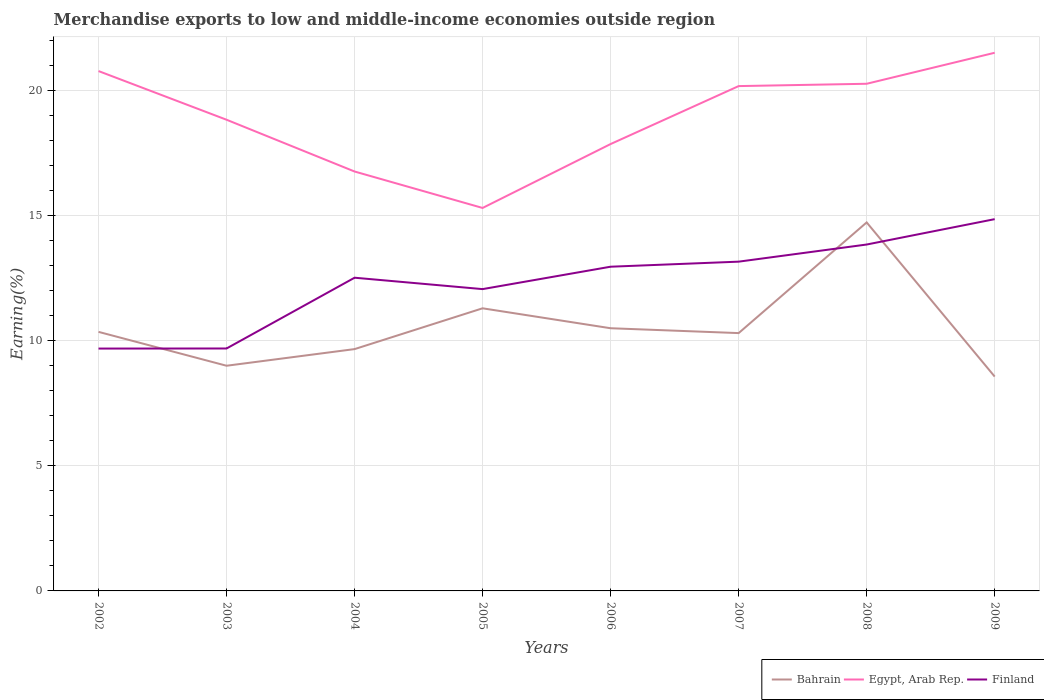How many different coloured lines are there?
Ensure brevity in your answer.  3. Does the line corresponding to Egypt, Arab Rep. intersect with the line corresponding to Finland?
Provide a succinct answer. No. Is the number of lines equal to the number of legend labels?
Offer a very short reply. Yes. Across all years, what is the maximum percentage of amount earned from merchandise exports in Bahrain?
Make the answer very short. 8.57. What is the total percentage of amount earned from merchandise exports in Egypt, Arab Rep. in the graph?
Make the answer very short. -1.1. What is the difference between the highest and the second highest percentage of amount earned from merchandise exports in Bahrain?
Offer a very short reply. 6.16. How many lines are there?
Your answer should be very brief. 3. What is the difference between two consecutive major ticks on the Y-axis?
Give a very brief answer. 5. Are the values on the major ticks of Y-axis written in scientific E-notation?
Keep it short and to the point. No. Does the graph contain any zero values?
Your answer should be very brief. No. Does the graph contain grids?
Your answer should be compact. Yes. How many legend labels are there?
Your response must be concise. 3. How are the legend labels stacked?
Offer a very short reply. Horizontal. What is the title of the graph?
Give a very brief answer. Merchandise exports to low and middle-income economies outside region. What is the label or title of the X-axis?
Make the answer very short. Years. What is the label or title of the Y-axis?
Ensure brevity in your answer.  Earning(%). What is the Earning(%) in Bahrain in 2002?
Give a very brief answer. 10.36. What is the Earning(%) of Egypt, Arab Rep. in 2002?
Provide a short and direct response. 20.78. What is the Earning(%) in Finland in 2002?
Your answer should be compact. 9.69. What is the Earning(%) in Bahrain in 2003?
Offer a very short reply. 9. What is the Earning(%) of Egypt, Arab Rep. in 2003?
Your answer should be very brief. 18.84. What is the Earning(%) of Finland in 2003?
Give a very brief answer. 9.69. What is the Earning(%) in Bahrain in 2004?
Make the answer very short. 9.67. What is the Earning(%) of Egypt, Arab Rep. in 2004?
Provide a succinct answer. 16.77. What is the Earning(%) of Finland in 2004?
Provide a short and direct response. 12.52. What is the Earning(%) of Bahrain in 2005?
Keep it short and to the point. 11.3. What is the Earning(%) in Egypt, Arab Rep. in 2005?
Your answer should be compact. 15.31. What is the Earning(%) in Finland in 2005?
Your response must be concise. 12.07. What is the Earning(%) in Bahrain in 2006?
Give a very brief answer. 10.5. What is the Earning(%) of Egypt, Arab Rep. in 2006?
Provide a succinct answer. 17.86. What is the Earning(%) in Finland in 2006?
Make the answer very short. 12.96. What is the Earning(%) in Bahrain in 2007?
Provide a succinct answer. 10.31. What is the Earning(%) in Egypt, Arab Rep. in 2007?
Make the answer very short. 20.18. What is the Earning(%) in Finland in 2007?
Provide a short and direct response. 13.16. What is the Earning(%) in Bahrain in 2008?
Ensure brevity in your answer.  14.73. What is the Earning(%) of Egypt, Arab Rep. in 2008?
Your response must be concise. 20.27. What is the Earning(%) of Finland in 2008?
Provide a succinct answer. 13.85. What is the Earning(%) of Bahrain in 2009?
Give a very brief answer. 8.57. What is the Earning(%) in Egypt, Arab Rep. in 2009?
Provide a short and direct response. 21.51. What is the Earning(%) in Finland in 2009?
Your answer should be very brief. 14.86. Across all years, what is the maximum Earning(%) in Bahrain?
Give a very brief answer. 14.73. Across all years, what is the maximum Earning(%) in Egypt, Arab Rep.?
Provide a short and direct response. 21.51. Across all years, what is the maximum Earning(%) of Finland?
Give a very brief answer. 14.86. Across all years, what is the minimum Earning(%) of Bahrain?
Ensure brevity in your answer.  8.57. Across all years, what is the minimum Earning(%) in Egypt, Arab Rep.?
Your answer should be very brief. 15.31. Across all years, what is the minimum Earning(%) in Finland?
Your answer should be compact. 9.69. What is the total Earning(%) in Bahrain in the graph?
Ensure brevity in your answer.  84.43. What is the total Earning(%) of Egypt, Arab Rep. in the graph?
Keep it short and to the point. 151.53. What is the total Earning(%) in Finland in the graph?
Make the answer very short. 98.8. What is the difference between the Earning(%) in Bahrain in 2002 and that in 2003?
Offer a terse response. 1.35. What is the difference between the Earning(%) of Egypt, Arab Rep. in 2002 and that in 2003?
Your response must be concise. 1.95. What is the difference between the Earning(%) in Finland in 2002 and that in 2003?
Provide a succinct answer. -0. What is the difference between the Earning(%) in Bahrain in 2002 and that in 2004?
Your answer should be very brief. 0.69. What is the difference between the Earning(%) of Egypt, Arab Rep. in 2002 and that in 2004?
Provide a succinct answer. 4.02. What is the difference between the Earning(%) of Finland in 2002 and that in 2004?
Offer a terse response. -2.83. What is the difference between the Earning(%) in Bahrain in 2002 and that in 2005?
Your answer should be compact. -0.94. What is the difference between the Earning(%) of Egypt, Arab Rep. in 2002 and that in 2005?
Provide a succinct answer. 5.47. What is the difference between the Earning(%) of Finland in 2002 and that in 2005?
Your answer should be compact. -2.38. What is the difference between the Earning(%) in Bahrain in 2002 and that in 2006?
Ensure brevity in your answer.  -0.14. What is the difference between the Earning(%) of Egypt, Arab Rep. in 2002 and that in 2006?
Offer a terse response. 2.92. What is the difference between the Earning(%) in Finland in 2002 and that in 2006?
Your answer should be compact. -3.27. What is the difference between the Earning(%) of Bahrain in 2002 and that in 2007?
Give a very brief answer. 0.05. What is the difference between the Earning(%) in Egypt, Arab Rep. in 2002 and that in 2007?
Give a very brief answer. 0.6. What is the difference between the Earning(%) in Finland in 2002 and that in 2007?
Provide a succinct answer. -3.47. What is the difference between the Earning(%) of Bahrain in 2002 and that in 2008?
Give a very brief answer. -4.38. What is the difference between the Earning(%) in Egypt, Arab Rep. in 2002 and that in 2008?
Provide a succinct answer. 0.51. What is the difference between the Earning(%) of Finland in 2002 and that in 2008?
Offer a terse response. -4.16. What is the difference between the Earning(%) in Bahrain in 2002 and that in 2009?
Offer a terse response. 1.79. What is the difference between the Earning(%) in Egypt, Arab Rep. in 2002 and that in 2009?
Your answer should be very brief. -0.73. What is the difference between the Earning(%) of Finland in 2002 and that in 2009?
Keep it short and to the point. -5.17. What is the difference between the Earning(%) in Bahrain in 2003 and that in 2004?
Provide a short and direct response. -0.67. What is the difference between the Earning(%) of Egypt, Arab Rep. in 2003 and that in 2004?
Give a very brief answer. 2.07. What is the difference between the Earning(%) in Finland in 2003 and that in 2004?
Keep it short and to the point. -2.83. What is the difference between the Earning(%) in Bahrain in 2003 and that in 2005?
Your answer should be compact. -2.3. What is the difference between the Earning(%) in Egypt, Arab Rep. in 2003 and that in 2005?
Offer a terse response. 3.53. What is the difference between the Earning(%) in Finland in 2003 and that in 2005?
Ensure brevity in your answer.  -2.37. What is the difference between the Earning(%) of Bahrain in 2003 and that in 2006?
Offer a terse response. -1.5. What is the difference between the Earning(%) in Egypt, Arab Rep. in 2003 and that in 2006?
Provide a succinct answer. 0.97. What is the difference between the Earning(%) in Finland in 2003 and that in 2006?
Offer a terse response. -3.27. What is the difference between the Earning(%) of Bahrain in 2003 and that in 2007?
Provide a short and direct response. -1.3. What is the difference between the Earning(%) in Egypt, Arab Rep. in 2003 and that in 2007?
Your answer should be compact. -1.34. What is the difference between the Earning(%) of Finland in 2003 and that in 2007?
Offer a very short reply. -3.47. What is the difference between the Earning(%) in Bahrain in 2003 and that in 2008?
Offer a terse response. -5.73. What is the difference between the Earning(%) of Egypt, Arab Rep. in 2003 and that in 2008?
Offer a terse response. -1.44. What is the difference between the Earning(%) of Finland in 2003 and that in 2008?
Provide a succinct answer. -4.16. What is the difference between the Earning(%) in Bahrain in 2003 and that in 2009?
Ensure brevity in your answer.  0.43. What is the difference between the Earning(%) of Egypt, Arab Rep. in 2003 and that in 2009?
Your response must be concise. -2.68. What is the difference between the Earning(%) in Finland in 2003 and that in 2009?
Your response must be concise. -5.17. What is the difference between the Earning(%) in Bahrain in 2004 and that in 2005?
Make the answer very short. -1.63. What is the difference between the Earning(%) in Egypt, Arab Rep. in 2004 and that in 2005?
Your response must be concise. 1.46. What is the difference between the Earning(%) of Finland in 2004 and that in 2005?
Offer a very short reply. 0.46. What is the difference between the Earning(%) in Bahrain in 2004 and that in 2006?
Offer a very short reply. -0.83. What is the difference between the Earning(%) in Egypt, Arab Rep. in 2004 and that in 2006?
Ensure brevity in your answer.  -1.1. What is the difference between the Earning(%) of Finland in 2004 and that in 2006?
Provide a succinct answer. -0.44. What is the difference between the Earning(%) in Bahrain in 2004 and that in 2007?
Ensure brevity in your answer.  -0.64. What is the difference between the Earning(%) in Egypt, Arab Rep. in 2004 and that in 2007?
Your answer should be compact. -3.41. What is the difference between the Earning(%) of Finland in 2004 and that in 2007?
Your response must be concise. -0.64. What is the difference between the Earning(%) in Bahrain in 2004 and that in 2008?
Your response must be concise. -5.06. What is the difference between the Earning(%) in Egypt, Arab Rep. in 2004 and that in 2008?
Your answer should be very brief. -3.51. What is the difference between the Earning(%) of Finland in 2004 and that in 2008?
Provide a short and direct response. -1.33. What is the difference between the Earning(%) of Bahrain in 2004 and that in 2009?
Make the answer very short. 1.1. What is the difference between the Earning(%) in Egypt, Arab Rep. in 2004 and that in 2009?
Your answer should be compact. -4.75. What is the difference between the Earning(%) of Finland in 2004 and that in 2009?
Your response must be concise. -2.34. What is the difference between the Earning(%) of Bahrain in 2005 and that in 2006?
Give a very brief answer. 0.8. What is the difference between the Earning(%) of Egypt, Arab Rep. in 2005 and that in 2006?
Provide a short and direct response. -2.56. What is the difference between the Earning(%) in Finland in 2005 and that in 2006?
Provide a succinct answer. -0.9. What is the difference between the Earning(%) in Bahrain in 2005 and that in 2007?
Your answer should be very brief. 0.99. What is the difference between the Earning(%) in Egypt, Arab Rep. in 2005 and that in 2007?
Offer a very short reply. -4.87. What is the difference between the Earning(%) in Finland in 2005 and that in 2007?
Offer a terse response. -1.1. What is the difference between the Earning(%) of Bahrain in 2005 and that in 2008?
Make the answer very short. -3.43. What is the difference between the Earning(%) in Egypt, Arab Rep. in 2005 and that in 2008?
Provide a short and direct response. -4.96. What is the difference between the Earning(%) in Finland in 2005 and that in 2008?
Keep it short and to the point. -1.78. What is the difference between the Earning(%) in Bahrain in 2005 and that in 2009?
Your answer should be very brief. 2.73. What is the difference between the Earning(%) in Egypt, Arab Rep. in 2005 and that in 2009?
Your answer should be compact. -6.2. What is the difference between the Earning(%) of Finland in 2005 and that in 2009?
Give a very brief answer. -2.8. What is the difference between the Earning(%) in Bahrain in 2006 and that in 2007?
Give a very brief answer. 0.19. What is the difference between the Earning(%) in Egypt, Arab Rep. in 2006 and that in 2007?
Offer a very short reply. -2.32. What is the difference between the Earning(%) of Finland in 2006 and that in 2007?
Make the answer very short. -0.2. What is the difference between the Earning(%) in Bahrain in 2006 and that in 2008?
Keep it short and to the point. -4.23. What is the difference between the Earning(%) of Egypt, Arab Rep. in 2006 and that in 2008?
Provide a short and direct response. -2.41. What is the difference between the Earning(%) in Finland in 2006 and that in 2008?
Your response must be concise. -0.89. What is the difference between the Earning(%) in Bahrain in 2006 and that in 2009?
Your response must be concise. 1.93. What is the difference between the Earning(%) of Egypt, Arab Rep. in 2006 and that in 2009?
Your response must be concise. -3.65. What is the difference between the Earning(%) in Finland in 2006 and that in 2009?
Ensure brevity in your answer.  -1.9. What is the difference between the Earning(%) of Bahrain in 2007 and that in 2008?
Make the answer very short. -4.42. What is the difference between the Earning(%) in Egypt, Arab Rep. in 2007 and that in 2008?
Offer a very short reply. -0.09. What is the difference between the Earning(%) of Finland in 2007 and that in 2008?
Give a very brief answer. -0.68. What is the difference between the Earning(%) of Bahrain in 2007 and that in 2009?
Your response must be concise. 1.74. What is the difference between the Earning(%) of Egypt, Arab Rep. in 2007 and that in 2009?
Offer a very short reply. -1.33. What is the difference between the Earning(%) in Finland in 2007 and that in 2009?
Give a very brief answer. -1.7. What is the difference between the Earning(%) of Bahrain in 2008 and that in 2009?
Offer a very short reply. 6.16. What is the difference between the Earning(%) of Egypt, Arab Rep. in 2008 and that in 2009?
Give a very brief answer. -1.24. What is the difference between the Earning(%) in Finland in 2008 and that in 2009?
Provide a short and direct response. -1.01. What is the difference between the Earning(%) in Bahrain in 2002 and the Earning(%) in Egypt, Arab Rep. in 2003?
Your answer should be compact. -8.48. What is the difference between the Earning(%) in Bahrain in 2002 and the Earning(%) in Finland in 2003?
Your response must be concise. 0.66. What is the difference between the Earning(%) of Egypt, Arab Rep. in 2002 and the Earning(%) of Finland in 2003?
Your answer should be very brief. 11.09. What is the difference between the Earning(%) in Bahrain in 2002 and the Earning(%) in Egypt, Arab Rep. in 2004?
Keep it short and to the point. -6.41. What is the difference between the Earning(%) of Bahrain in 2002 and the Earning(%) of Finland in 2004?
Your response must be concise. -2.16. What is the difference between the Earning(%) of Egypt, Arab Rep. in 2002 and the Earning(%) of Finland in 2004?
Give a very brief answer. 8.26. What is the difference between the Earning(%) of Bahrain in 2002 and the Earning(%) of Egypt, Arab Rep. in 2005?
Keep it short and to the point. -4.95. What is the difference between the Earning(%) in Bahrain in 2002 and the Earning(%) in Finland in 2005?
Your response must be concise. -1.71. What is the difference between the Earning(%) in Egypt, Arab Rep. in 2002 and the Earning(%) in Finland in 2005?
Make the answer very short. 8.72. What is the difference between the Earning(%) of Bahrain in 2002 and the Earning(%) of Egypt, Arab Rep. in 2006?
Your response must be concise. -7.51. What is the difference between the Earning(%) of Bahrain in 2002 and the Earning(%) of Finland in 2006?
Give a very brief answer. -2.6. What is the difference between the Earning(%) of Egypt, Arab Rep. in 2002 and the Earning(%) of Finland in 2006?
Your response must be concise. 7.82. What is the difference between the Earning(%) of Bahrain in 2002 and the Earning(%) of Egypt, Arab Rep. in 2007?
Your answer should be compact. -9.83. What is the difference between the Earning(%) in Bahrain in 2002 and the Earning(%) in Finland in 2007?
Offer a terse response. -2.81. What is the difference between the Earning(%) in Egypt, Arab Rep. in 2002 and the Earning(%) in Finland in 2007?
Give a very brief answer. 7.62. What is the difference between the Earning(%) in Bahrain in 2002 and the Earning(%) in Egypt, Arab Rep. in 2008?
Give a very brief answer. -9.92. What is the difference between the Earning(%) in Bahrain in 2002 and the Earning(%) in Finland in 2008?
Ensure brevity in your answer.  -3.49. What is the difference between the Earning(%) of Egypt, Arab Rep. in 2002 and the Earning(%) of Finland in 2008?
Give a very brief answer. 6.93. What is the difference between the Earning(%) in Bahrain in 2002 and the Earning(%) in Egypt, Arab Rep. in 2009?
Provide a succinct answer. -11.16. What is the difference between the Earning(%) of Bahrain in 2002 and the Earning(%) of Finland in 2009?
Your answer should be compact. -4.51. What is the difference between the Earning(%) in Egypt, Arab Rep. in 2002 and the Earning(%) in Finland in 2009?
Offer a very short reply. 5.92. What is the difference between the Earning(%) in Bahrain in 2003 and the Earning(%) in Egypt, Arab Rep. in 2004?
Your answer should be very brief. -7.76. What is the difference between the Earning(%) of Bahrain in 2003 and the Earning(%) of Finland in 2004?
Provide a short and direct response. -3.52. What is the difference between the Earning(%) of Egypt, Arab Rep. in 2003 and the Earning(%) of Finland in 2004?
Offer a very short reply. 6.32. What is the difference between the Earning(%) of Bahrain in 2003 and the Earning(%) of Egypt, Arab Rep. in 2005?
Your answer should be compact. -6.31. What is the difference between the Earning(%) in Bahrain in 2003 and the Earning(%) in Finland in 2005?
Your response must be concise. -3.06. What is the difference between the Earning(%) of Egypt, Arab Rep. in 2003 and the Earning(%) of Finland in 2005?
Offer a very short reply. 6.77. What is the difference between the Earning(%) of Bahrain in 2003 and the Earning(%) of Egypt, Arab Rep. in 2006?
Ensure brevity in your answer.  -8.86. What is the difference between the Earning(%) of Bahrain in 2003 and the Earning(%) of Finland in 2006?
Ensure brevity in your answer.  -3.96. What is the difference between the Earning(%) in Egypt, Arab Rep. in 2003 and the Earning(%) in Finland in 2006?
Your response must be concise. 5.88. What is the difference between the Earning(%) in Bahrain in 2003 and the Earning(%) in Egypt, Arab Rep. in 2007?
Your answer should be compact. -11.18. What is the difference between the Earning(%) in Bahrain in 2003 and the Earning(%) in Finland in 2007?
Offer a very short reply. -4.16. What is the difference between the Earning(%) in Egypt, Arab Rep. in 2003 and the Earning(%) in Finland in 2007?
Provide a succinct answer. 5.67. What is the difference between the Earning(%) of Bahrain in 2003 and the Earning(%) of Egypt, Arab Rep. in 2008?
Offer a very short reply. -11.27. What is the difference between the Earning(%) in Bahrain in 2003 and the Earning(%) in Finland in 2008?
Keep it short and to the point. -4.85. What is the difference between the Earning(%) of Egypt, Arab Rep. in 2003 and the Earning(%) of Finland in 2008?
Ensure brevity in your answer.  4.99. What is the difference between the Earning(%) of Bahrain in 2003 and the Earning(%) of Egypt, Arab Rep. in 2009?
Offer a very short reply. -12.51. What is the difference between the Earning(%) in Bahrain in 2003 and the Earning(%) in Finland in 2009?
Offer a terse response. -5.86. What is the difference between the Earning(%) in Egypt, Arab Rep. in 2003 and the Earning(%) in Finland in 2009?
Your answer should be compact. 3.97. What is the difference between the Earning(%) of Bahrain in 2004 and the Earning(%) of Egypt, Arab Rep. in 2005?
Keep it short and to the point. -5.64. What is the difference between the Earning(%) in Bahrain in 2004 and the Earning(%) in Finland in 2005?
Make the answer very short. -2.4. What is the difference between the Earning(%) of Egypt, Arab Rep. in 2004 and the Earning(%) of Finland in 2005?
Provide a succinct answer. 4.7. What is the difference between the Earning(%) in Bahrain in 2004 and the Earning(%) in Egypt, Arab Rep. in 2006?
Give a very brief answer. -8.2. What is the difference between the Earning(%) in Bahrain in 2004 and the Earning(%) in Finland in 2006?
Your response must be concise. -3.29. What is the difference between the Earning(%) of Egypt, Arab Rep. in 2004 and the Earning(%) of Finland in 2006?
Your answer should be compact. 3.81. What is the difference between the Earning(%) of Bahrain in 2004 and the Earning(%) of Egypt, Arab Rep. in 2007?
Give a very brief answer. -10.51. What is the difference between the Earning(%) in Bahrain in 2004 and the Earning(%) in Finland in 2007?
Ensure brevity in your answer.  -3.5. What is the difference between the Earning(%) of Egypt, Arab Rep. in 2004 and the Earning(%) of Finland in 2007?
Make the answer very short. 3.6. What is the difference between the Earning(%) in Bahrain in 2004 and the Earning(%) in Egypt, Arab Rep. in 2008?
Your answer should be compact. -10.61. What is the difference between the Earning(%) of Bahrain in 2004 and the Earning(%) of Finland in 2008?
Your answer should be very brief. -4.18. What is the difference between the Earning(%) of Egypt, Arab Rep. in 2004 and the Earning(%) of Finland in 2008?
Offer a terse response. 2.92. What is the difference between the Earning(%) in Bahrain in 2004 and the Earning(%) in Egypt, Arab Rep. in 2009?
Provide a succinct answer. -11.85. What is the difference between the Earning(%) of Bahrain in 2004 and the Earning(%) of Finland in 2009?
Make the answer very short. -5.2. What is the difference between the Earning(%) of Egypt, Arab Rep. in 2004 and the Earning(%) of Finland in 2009?
Your answer should be compact. 1.9. What is the difference between the Earning(%) of Bahrain in 2005 and the Earning(%) of Egypt, Arab Rep. in 2006?
Your answer should be very brief. -6.57. What is the difference between the Earning(%) in Bahrain in 2005 and the Earning(%) in Finland in 2006?
Offer a very short reply. -1.66. What is the difference between the Earning(%) in Egypt, Arab Rep. in 2005 and the Earning(%) in Finland in 2006?
Provide a short and direct response. 2.35. What is the difference between the Earning(%) of Bahrain in 2005 and the Earning(%) of Egypt, Arab Rep. in 2007?
Your response must be concise. -8.88. What is the difference between the Earning(%) in Bahrain in 2005 and the Earning(%) in Finland in 2007?
Keep it short and to the point. -1.86. What is the difference between the Earning(%) of Egypt, Arab Rep. in 2005 and the Earning(%) of Finland in 2007?
Provide a short and direct response. 2.15. What is the difference between the Earning(%) of Bahrain in 2005 and the Earning(%) of Egypt, Arab Rep. in 2008?
Provide a succinct answer. -8.98. What is the difference between the Earning(%) in Bahrain in 2005 and the Earning(%) in Finland in 2008?
Keep it short and to the point. -2.55. What is the difference between the Earning(%) in Egypt, Arab Rep. in 2005 and the Earning(%) in Finland in 2008?
Give a very brief answer. 1.46. What is the difference between the Earning(%) in Bahrain in 2005 and the Earning(%) in Egypt, Arab Rep. in 2009?
Your response must be concise. -10.22. What is the difference between the Earning(%) in Bahrain in 2005 and the Earning(%) in Finland in 2009?
Provide a short and direct response. -3.56. What is the difference between the Earning(%) of Egypt, Arab Rep. in 2005 and the Earning(%) of Finland in 2009?
Give a very brief answer. 0.45. What is the difference between the Earning(%) in Bahrain in 2006 and the Earning(%) in Egypt, Arab Rep. in 2007?
Your answer should be compact. -9.68. What is the difference between the Earning(%) of Bahrain in 2006 and the Earning(%) of Finland in 2007?
Keep it short and to the point. -2.66. What is the difference between the Earning(%) of Egypt, Arab Rep. in 2006 and the Earning(%) of Finland in 2007?
Provide a short and direct response. 4.7. What is the difference between the Earning(%) in Bahrain in 2006 and the Earning(%) in Egypt, Arab Rep. in 2008?
Provide a short and direct response. -9.77. What is the difference between the Earning(%) of Bahrain in 2006 and the Earning(%) of Finland in 2008?
Provide a short and direct response. -3.35. What is the difference between the Earning(%) of Egypt, Arab Rep. in 2006 and the Earning(%) of Finland in 2008?
Ensure brevity in your answer.  4.02. What is the difference between the Earning(%) in Bahrain in 2006 and the Earning(%) in Egypt, Arab Rep. in 2009?
Make the answer very short. -11.01. What is the difference between the Earning(%) in Bahrain in 2006 and the Earning(%) in Finland in 2009?
Your answer should be compact. -4.36. What is the difference between the Earning(%) of Egypt, Arab Rep. in 2006 and the Earning(%) of Finland in 2009?
Make the answer very short. 3. What is the difference between the Earning(%) in Bahrain in 2007 and the Earning(%) in Egypt, Arab Rep. in 2008?
Keep it short and to the point. -9.97. What is the difference between the Earning(%) in Bahrain in 2007 and the Earning(%) in Finland in 2008?
Keep it short and to the point. -3.54. What is the difference between the Earning(%) in Egypt, Arab Rep. in 2007 and the Earning(%) in Finland in 2008?
Your response must be concise. 6.33. What is the difference between the Earning(%) in Bahrain in 2007 and the Earning(%) in Egypt, Arab Rep. in 2009?
Keep it short and to the point. -11.21. What is the difference between the Earning(%) in Bahrain in 2007 and the Earning(%) in Finland in 2009?
Your answer should be very brief. -4.56. What is the difference between the Earning(%) of Egypt, Arab Rep. in 2007 and the Earning(%) of Finland in 2009?
Ensure brevity in your answer.  5.32. What is the difference between the Earning(%) in Bahrain in 2008 and the Earning(%) in Egypt, Arab Rep. in 2009?
Offer a very short reply. -6.78. What is the difference between the Earning(%) in Bahrain in 2008 and the Earning(%) in Finland in 2009?
Give a very brief answer. -0.13. What is the difference between the Earning(%) of Egypt, Arab Rep. in 2008 and the Earning(%) of Finland in 2009?
Your answer should be very brief. 5.41. What is the average Earning(%) in Bahrain per year?
Offer a very short reply. 10.55. What is the average Earning(%) of Egypt, Arab Rep. per year?
Offer a terse response. 18.94. What is the average Earning(%) in Finland per year?
Your answer should be compact. 12.35. In the year 2002, what is the difference between the Earning(%) in Bahrain and Earning(%) in Egypt, Arab Rep.?
Keep it short and to the point. -10.43. In the year 2002, what is the difference between the Earning(%) of Bahrain and Earning(%) of Finland?
Make the answer very short. 0.67. In the year 2002, what is the difference between the Earning(%) in Egypt, Arab Rep. and Earning(%) in Finland?
Provide a succinct answer. 11.09. In the year 2003, what is the difference between the Earning(%) in Bahrain and Earning(%) in Egypt, Arab Rep.?
Your answer should be very brief. -9.83. In the year 2003, what is the difference between the Earning(%) of Bahrain and Earning(%) of Finland?
Provide a succinct answer. -0.69. In the year 2003, what is the difference between the Earning(%) in Egypt, Arab Rep. and Earning(%) in Finland?
Offer a terse response. 9.14. In the year 2004, what is the difference between the Earning(%) in Bahrain and Earning(%) in Egypt, Arab Rep.?
Keep it short and to the point. -7.1. In the year 2004, what is the difference between the Earning(%) of Bahrain and Earning(%) of Finland?
Offer a terse response. -2.85. In the year 2004, what is the difference between the Earning(%) of Egypt, Arab Rep. and Earning(%) of Finland?
Your answer should be very brief. 4.25. In the year 2005, what is the difference between the Earning(%) of Bahrain and Earning(%) of Egypt, Arab Rep.?
Offer a very short reply. -4.01. In the year 2005, what is the difference between the Earning(%) in Bahrain and Earning(%) in Finland?
Offer a terse response. -0.77. In the year 2005, what is the difference between the Earning(%) in Egypt, Arab Rep. and Earning(%) in Finland?
Your answer should be compact. 3.24. In the year 2006, what is the difference between the Earning(%) of Bahrain and Earning(%) of Egypt, Arab Rep.?
Give a very brief answer. -7.36. In the year 2006, what is the difference between the Earning(%) in Bahrain and Earning(%) in Finland?
Your answer should be compact. -2.46. In the year 2006, what is the difference between the Earning(%) of Egypt, Arab Rep. and Earning(%) of Finland?
Offer a terse response. 4.9. In the year 2007, what is the difference between the Earning(%) of Bahrain and Earning(%) of Egypt, Arab Rep.?
Your answer should be very brief. -9.87. In the year 2007, what is the difference between the Earning(%) in Bahrain and Earning(%) in Finland?
Ensure brevity in your answer.  -2.86. In the year 2007, what is the difference between the Earning(%) in Egypt, Arab Rep. and Earning(%) in Finland?
Give a very brief answer. 7.02. In the year 2008, what is the difference between the Earning(%) of Bahrain and Earning(%) of Egypt, Arab Rep.?
Offer a terse response. -5.54. In the year 2008, what is the difference between the Earning(%) of Bahrain and Earning(%) of Finland?
Keep it short and to the point. 0.88. In the year 2008, what is the difference between the Earning(%) in Egypt, Arab Rep. and Earning(%) in Finland?
Give a very brief answer. 6.43. In the year 2009, what is the difference between the Earning(%) in Bahrain and Earning(%) in Egypt, Arab Rep.?
Offer a very short reply. -12.95. In the year 2009, what is the difference between the Earning(%) in Bahrain and Earning(%) in Finland?
Keep it short and to the point. -6.29. In the year 2009, what is the difference between the Earning(%) of Egypt, Arab Rep. and Earning(%) of Finland?
Keep it short and to the point. 6.65. What is the ratio of the Earning(%) in Bahrain in 2002 to that in 2003?
Your answer should be compact. 1.15. What is the ratio of the Earning(%) in Egypt, Arab Rep. in 2002 to that in 2003?
Offer a very short reply. 1.1. What is the ratio of the Earning(%) of Finland in 2002 to that in 2003?
Give a very brief answer. 1. What is the ratio of the Earning(%) in Bahrain in 2002 to that in 2004?
Offer a very short reply. 1.07. What is the ratio of the Earning(%) in Egypt, Arab Rep. in 2002 to that in 2004?
Your answer should be very brief. 1.24. What is the ratio of the Earning(%) in Finland in 2002 to that in 2004?
Make the answer very short. 0.77. What is the ratio of the Earning(%) of Bahrain in 2002 to that in 2005?
Make the answer very short. 0.92. What is the ratio of the Earning(%) of Egypt, Arab Rep. in 2002 to that in 2005?
Make the answer very short. 1.36. What is the ratio of the Earning(%) of Finland in 2002 to that in 2005?
Provide a short and direct response. 0.8. What is the ratio of the Earning(%) of Bahrain in 2002 to that in 2006?
Your response must be concise. 0.99. What is the ratio of the Earning(%) in Egypt, Arab Rep. in 2002 to that in 2006?
Offer a very short reply. 1.16. What is the ratio of the Earning(%) of Finland in 2002 to that in 2006?
Your answer should be very brief. 0.75. What is the ratio of the Earning(%) of Egypt, Arab Rep. in 2002 to that in 2007?
Ensure brevity in your answer.  1.03. What is the ratio of the Earning(%) in Finland in 2002 to that in 2007?
Offer a terse response. 0.74. What is the ratio of the Earning(%) in Bahrain in 2002 to that in 2008?
Offer a terse response. 0.7. What is the ratio of the Earning(%) of Egypt, Arab Rep. in 2002 to that in 2008?
Provide a succinct answer. 1.03. What is the ratio of the Earning(%) in Finland in 2002 to that in 2008?
Offer a terse response. 0.7. What is the ratio of the Earning(%) in Bahrain in 2002 to that in 2009?
Your answer should be very brief. 1.21. What is the ratio of the Earning(%) of Finland in 2002 to that in 2009?
Ensure brevity in your answer.  0.65. What is the ratio of the Earning(%) in Bahrain in 2003 to that in 2004?
Give a very brief answer. 0.93. What is the ratio of the Earning(%) of Egypt, Arab Rep. in 2003 to that in 2004?
Your answer should be compact. 1.12. What is the ratio of the Earning(%) of Finland in 2003 to that in 2004?
Give a very brief answer. 0.77. What is the ratio of the Earning(%) in Bahrain in 2003 to that in 2005?
Provide a short and direct response. 0.8. What is the ratio of the Earning(%) in Egypt, Arab Rep. in 2003 to that in 2005?
Offer a terse response. 1.23. What is the ratio of the Earning(%) in Finland in 2003 to that in 2005?
Offer a terse response. 0.8. What is the ratio of the Earning(%) in Bahrain in 2003 to that in 2006?
Your answer should be very brief. 0.86. What is the ratio of the Earning(%) in Egypt, Arab Rep. in 2003 to that in 2006?
Make the answer very short. 1.05. What is the ratio of the Earning(%) in Finland in 2003 to that in 2006?
Your response must be concise. 0.75. What is the ratio of the Earning(%) in Bahrain in 2003 to that in 2007?
Give a very brief answer. 0.87. What is the ratio of the Earning(%) in Egypt, Arab Rep. in 2003 to that in 2007?
Keep it short and to the point. 0.93. What is the ratio of the Earning(%) in Finland in 2003 to that in 2007?
Your answer should be compact. 0.74. What is the ratio of the Earning(%) of Bahrain in 2003 to that in 2008?
Your answer should be very brief. 0.61. What is the ratio of the Earning(%) in Egypt, Arab Rep. in 2003 to that in 2008?
Your answer should be compact. 0.93. What is the ratio of the Earning(%) of Finland in 2003 to that in 2008?
Your response must be concise. 0.7. What is the ratio of the Earning(%) of Bahrain in 2003 to that in 2009?
Give a very brief answer. 1.05. What is the ratio of the Earning(%) in Egypt, Arab Rep. in 2003 to that in 2009?
Ensure brevity in your answer.  0.88. What is the ratio of the Earning(%) in Finland in 2003 to that in 2009?
Your answer should be compact. 0.65. What is the ratio of the Earning(%) in Bahrain in 2004 to that in 2005?
Offer a very short reply. 0.86. What is the ratio of the Earning(%) in Egypt, Arab Rep. in 2004 to that in 2005?
Offer a very short reply. 1.1. What is the ratio of the Earning(%) of Finland in 2004 to that in 2005?
Offer a terse response. 1.04. What is the ratio of the Earning(%) of Bahrain in 2004 to that in 2006?
Your response must be concise. 0.92. What is the ratio of the Earning(%) in Egypt, Arab Rep. in 2004 to that in 2006?
Offer a very short reply. 0.94. What is the ratio of the Earning(%) in Finland in 2004 to that in 2006?
Keep it short and to the point. 0.97. What is the ratio of the Earning(%) in Bahrain in 2004 to that in 2007?
Your answer should be very brief. 0.94. What is the ratio of the Earning(%) of Egypt, Arab Rep. in 2004 to that in 2007?
Provide a succinct answer. 0.83. What is the ratio of the Earning(%) in Finland in 2004 to that in 2007?
Provide a short and direct response. 0.95. What is the ratio of the Earning(%) of Bahrain in 2004 to that in 2008?
Keep it short and to the point. 0.66. What is the ratio of the Earning(%) of Egypt, Arab Rep. in 2004 to that in 2008?
Your response must be concise. 0.83. What is the ratio of the Earning(%) of Finland in 2004 to that in 2008?
Ensure brevity in your answer.  0.9. What is the ratio of the Earning(%) in Bahrain in 2004 to that in 2009?
Give a very brief answer. 1.13. What is the ratio of the Earning(%) of Egypt, Arab Rep. in 2004 to that in 2009?
Offer a terse response. 0.78. What is the ratio of the Earning(%) of Finland in 2004 to that in 2009?
Keep it short and to the point. 0.84. What is the ratio of the Earning(%) in Bahrain in 2005 to that in 2006?
Provide a short and direct response. 1.08. What is the ratio of the Earning(%) of Egypt, Arab Rep. in 2005 to that in 2006?
Offer a terse response. 0.86. What is the ratio of the Earning(%) in Finland in 2005 to that in 2006?
Ensure brevity in your answer.  0.93. What is the ratio of the Earning(%) of Bahrain in 2005 to that in 2007?
Provide a succinct answer. 1.1. What is the ratio of the Earning(%) in Egypt, Arab Rep. in 2005 to that in 2007?
Give a very brief answer. 0.76. What is the ratio of the Earning(%) in Finland in 2005 to that in 2007?
Give a very brief answer. 0.92. What is the ratio of the Earning(%) of Bahrain in 2005 to that in 2008?
Ensure brevity in your answer.  0.77. What is the ratio of the Earning(%) in Egypt, Arab Rep. in 2005 to that in 2008?
Your answer should be compact. 0.76. What is the ratio of the Earning(%) in Finland in 2005 to that in 2008?
Give a very brief answer. 0.87. What is the ratio of the Earning(%) of Bahrain in 2005 to that in 2009?
Your answer should be very brief. 1.32. What is the ratio of the Earning(%) of Egypt, Arab Rep. in 2005 to that in 2009?
Offer a terse response. 0.71. What is the ratio of the Earning(%) of Finland in 2005 to that in 2009?
Make the answer very short. 0.81. What is the ratio of the Earning(%) of Bahrain in 2006 to that in 2007?
Your response must be concise. 1.02. What is the ratio of the Earning(%) of Egypt, Arab Rep. in 2006 to that in 2007?
Your answer should be compact. 0.89. What is the ratio of the Earning(%) in Finland in 2006 to that in 2007?
Your answer should be very brief. 0.98. What is the ratio of the Earning(%) in Bahrain in 2006 to that in 2008?
Offer a very short reply. 0.71. What is the ratio of the Earning(%) in Egypt, Arab Rep. in 2006 to that in 2008?
Your answer should be very brief. 0.88. What is the ratio of the Earning(%) of Finland in 2006 to that in 2008?
Offer a very short reply. 0.94. What is the ratio of the Earning(%) in Bahrain in 2006 to that in 2009?
Provide a succinct answer. 1.23. What is the ratio of the Earning(%) of Egypt, Arab Rep. in 2006 to that in 2009?
Provide a short and direct response. 0.83. What is the ratio of the Earning(%) in Finland in 2006 to that in 2009?
Keep it short and to the point. 0.87. What is the ratio of the Earning(%) in Bahrain in 2007 to that in 2008?
Give a very brief answer. 0.7. What is the ratio of the Earning(%) in Finland in 2007 to that in 2008?
Make the answer very short. 0.95. What is the ratio of the Earning(%) of Bahrain in 2007 to that in 2009?
Offer a very short reply. 1.2. What is the ratio of the Earning(%) in Egypt, Arab Rep. in 2007 to that in 2009?
Keep it short and to the point. 0.94. What is the ratio of the Earning(%) of Finland in 2007 to that in 2009?
Your answer should be compact. 0.89. What is the ratio of the Earning(%) in Bahrain in 2008 to that in 2009?
Ensure brevity in your answer.  1.72. What is the ratio of the Earning(%) in Egypt, Arab Rep. in 2008 to that in 2009?
Your response must be concise. 0.94. What is the ratio of the Earning(%) in Finland in 2008 to that in 2009?
Give a very brief answer. 0.93. What is the difference between the highest and the second highest Earning(%) in Bahrain?
Your answer should be compact. 3.43. What is the difference between the highest and the second highest Earning(%) of Egypt, Arab Rep.?
Your response must be concise. 0.73. What is the difference between the highest and the second highest Earning(%) in Finland?
Offer a very short reply. 1.01. What is the difference between the highest and the lowest Earning(%) in Bahrain?
Your response must be concise. 6.16. What is the difference between the highest and the lowest Earning(%) of Egypt, Arab Rep.?
Ensure brevity in your answer.  6.2. What is the difference between the highest and the lowest Earning(%) in Finland?
Offer a terse response. 5.17. 